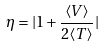<formula> <loc_0><loc_0><loc_500><loc_500>\eta = | 1 + \frac { \langle V \rangle } { 2 \langle T \rangle } |</formula> 